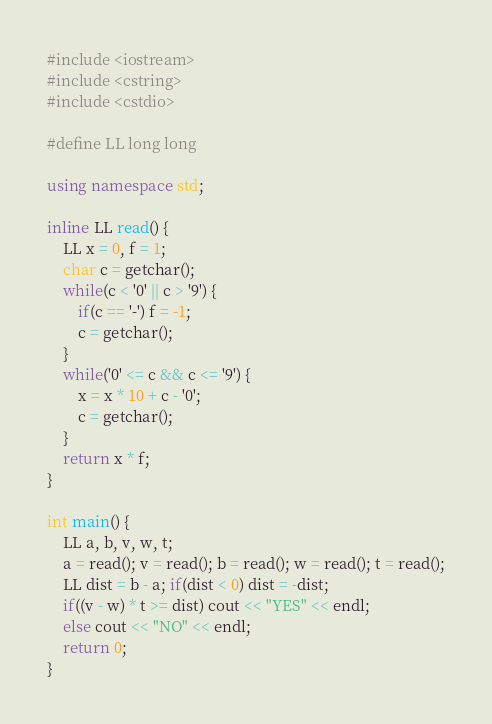<code> <loc_0><loc_0><loc_500><loc_500><_C++_>#include <iostream>
#include <cstring>
#include <cstdio>

#define LL long long

using namespace std;

inline LL read() {
    LL x = 0, f = 1;
    char c = getchar();
    while(c < '0' || c > '9') {
        if(c == '-') f = -1;
        c = getchar();
    }
    while('0' <= c && c <= '9') {
        x = x * 10 + c - '0';
        c = getchar();
    }
    return x * f;
}

int main() {
    LL a, b, v, w, t;
    a = read(); v = read(); b = read(); w = read(); t = read();
    LL dist = b - a; if(dist < 0) dist = -dist;
    if((v - w) * t >= dist) cout << "YES" << endl;
    else cout << "NO" << endl;
    return 0;
}</code> 